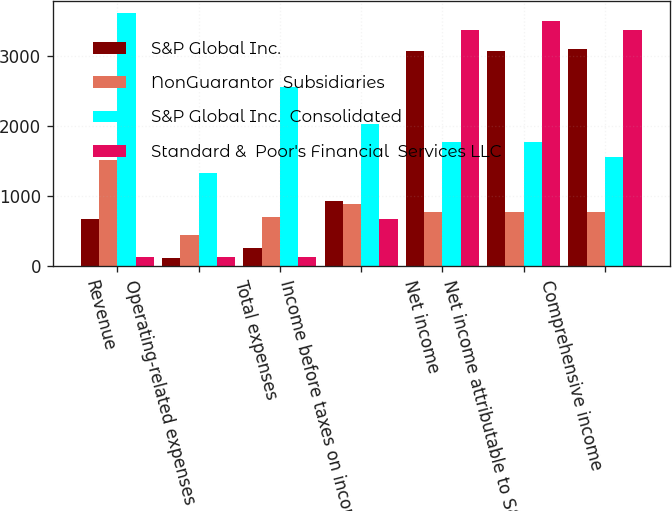Convert chart. <chart><loc_0><loc_0><loc_500><loc_500><stacked_bar_chart><ecel><fcel>Revenue<fcel>Operating-related expenses<fcel>Total expenses<fcel>Income before taxes on income<fcel>Net income<fcel>Net income attributable to S&P<fcel>Comprehensive income<nl><fcel>S&P Global Inc.<fcel>667<fcel>113<fcel>260<fcel>932<fcel>3069<fcel>3069<fcel>3099<nl><fcel>NonGuarantor  Subsidiaries<fcel>1513<fcel>451<fcel>703<fcel>893<fcel>767<fcel>767<fcel>767<nl><fcel>S&P Global Inc.  Consolidated<fcel>3607<fcel>1335<fcel>2556<fcel>2031<fcel>1766<fcel>1766<fcel>1563<nl><fcel>Standard &  Poor's Financial  Services LLC<fcel>126<fcel>126<fcel>126<fcel>668<fcel>3374<fcel>3496<fcel>3374<nl></chart> 